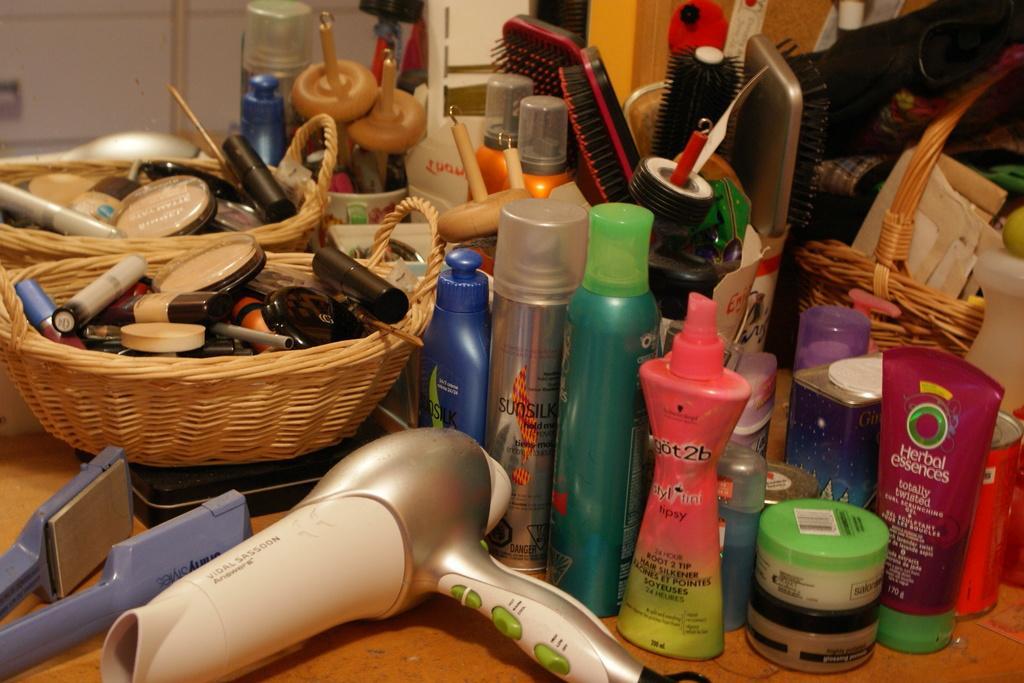<image>
Render a clear and concise summary of the photo. herbal essences hair product is one of the things on the table 